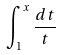<formula> <loc_0><loc_0><loc_500><loc_500>\int _ { 1 } ^ { x } \frac { d t } { t }</formula> 